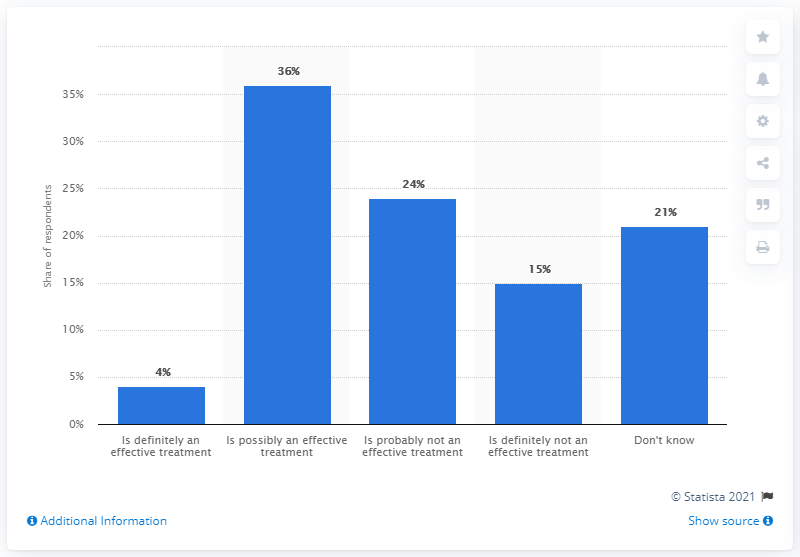Give some essential details in this illustration. The ratio of the first and second values is 1.5. The opinion that has the highest percentage is that which is possibly an effective treatment. 